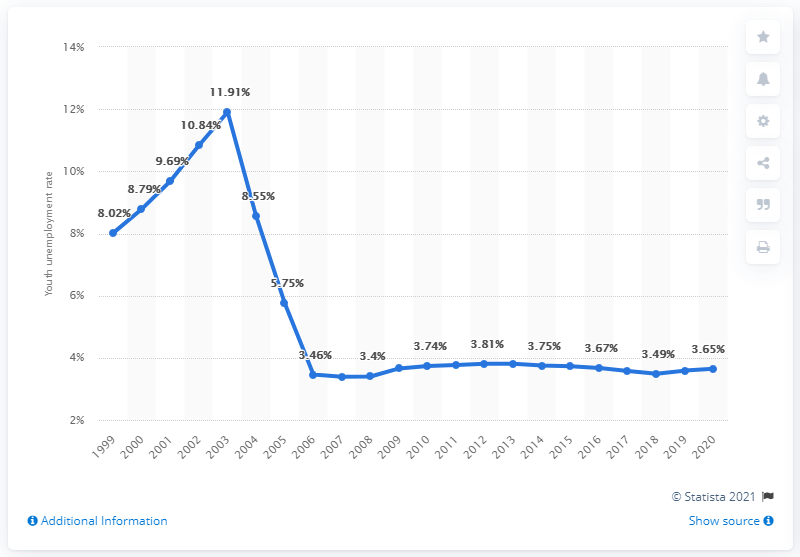Identify some key points in this picture. The youth unemployment rate in Tonga was 3.65% in 2020, according to recent data. 